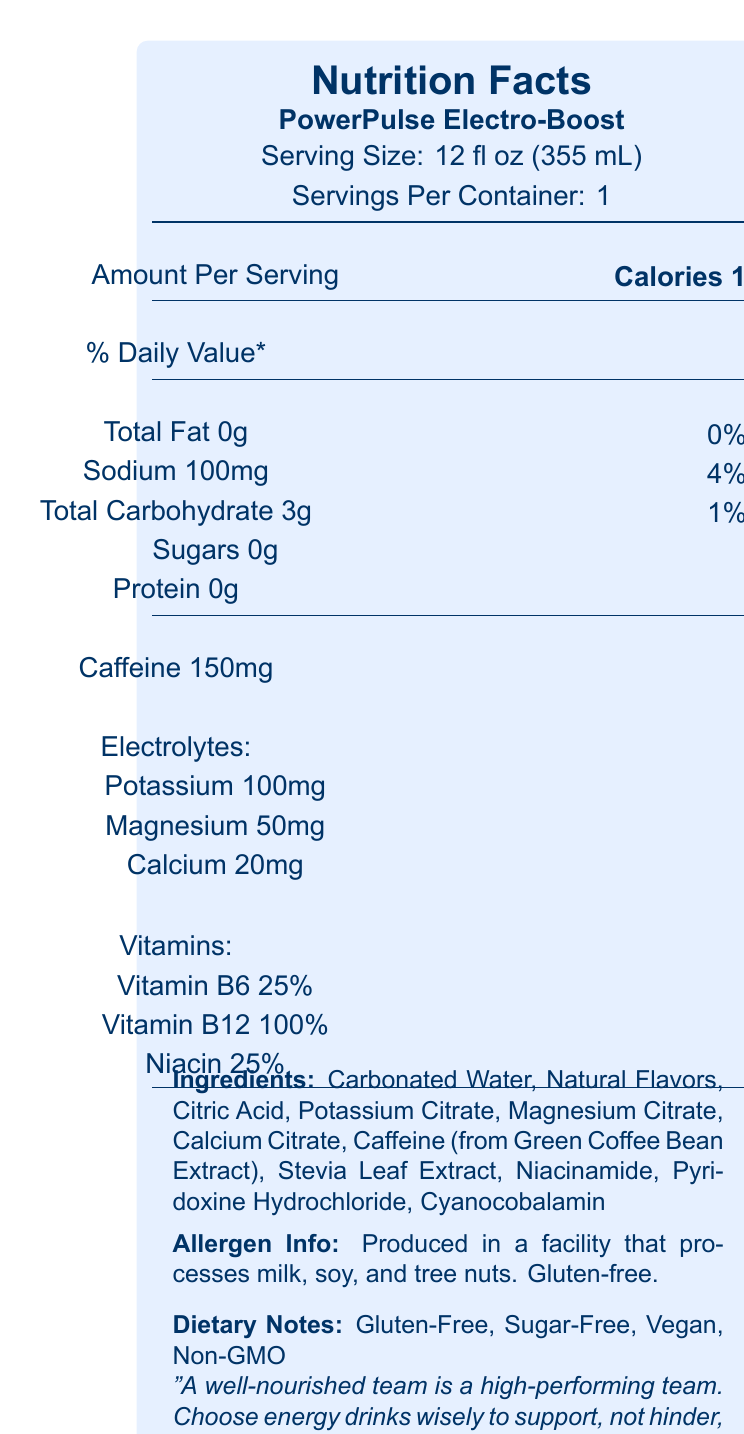what is the serving size of PowerPulse Electro-Boost? The serving size is specified in the document as 12 fl oz (355 mL).
Answer: 12 fl oz (355 mL) how many calories are in one serving of PowerPulse Electro-Boost? The document states that there are 10 calories per serving.
Answer: 10 how much caffeine does a serving of PowerPulse Electro-Boost contain? The document specifies that there are 150 mg of caffeine per serving.
Answer: 150 mg list the electrolytes found in PowerPulse Electro-Boost. The electrolytes listed in the document are Potassium, Magnesium, and Calcium.
Answer: Potassium, Magnesium, Calcium what percentage of Vitamin B12 is in one serving? According to the document, one serving contains 100% of the daily value of Vitamin B12.
Answer: 100% how many grams of sugars are in one serving? The document indicates that there are 0 grams of sugars in one serving.
Answer: 0 grams what is the total carbohydrate content? A. 1g B. 0g C. 3g D. 5g The document lists the total carbohydrate content as 3 grams.
Answer: C. 3g which ingredients are sourced from natural flavors? A. Stevia Leaf Extract B. Carbonated Water C. Natural Flavors D. Citric Acid The ingredient "Natural Flavors" is explicitly listed, whereas other ingredients are specifically named.
Answer: C. Natural Flavors is PowerPulse Electro-Boost gluten-free? The document states that this product is gluten-free.
Answer: Yes what is the primary aim of the "Team Energy Boost" HR wellness initiative? The document mentions that the goal of the "Team Energy Boost" initiative is to encourage balanced energy management to enhance team productivity.
Answer: Encouraging balanced energy management for improved team productivity what allergens may be present in the production facility? The document indicates that the product is produced in a facility that processes milk, soy, and tree nuts.
Answer: Milk, soy, tree nuts identify one dietary note about PowerPulse Electro-Boost. The document mentions that the product is sugar-free.
Answer: Sugar-Free describe the marketing claims made for PowerPulse Electro-Boost. The document outlines these three primary marketing claims to convey the benefits of the product.
Answer: The marketing claims emphasize supporting mental focus, enhancing physical performance, and promoting hydration. what is the total fat content of PowerPulse Electro-Boost? The document indicates that there is 0 grams of total fat per serving.
Answer: 0 grams What is the source of caffeine in PowerPulse Electro-Boost? A. Synthetic caffeine B. Black tea extract C. Green coffee bean extract D. Guarana seed extract The document specifies that the caffeine is sourced from Green Coffee Bean Extract.
Answer: C. Green coffee bean extract what is the wisdom shared from the HR manager's father? The document includes this piece of advice regarding team wellness and nutrition.
Answer: "Remember, a well-nourished team is a high-performing team. Choose energy drinks wisely to support, not hinder, your staff's wellbeing." who manufactures PowerPulse Electro-Boost? The document does not provide information about the manufacturer.
Answer: Cannot be determined 